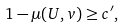Convert formula to latex. <formula><loc_0><loc_0><loc_500><loc_500>1 - \mu ( U , v ) \geq c ^ { \prime } ,</formula> 